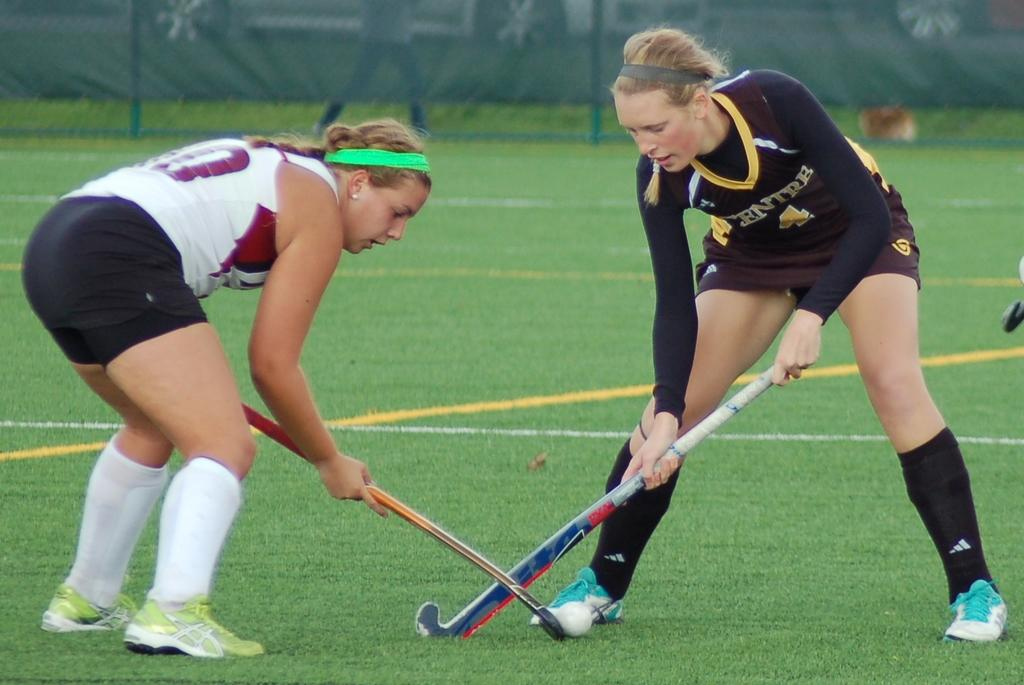How many people are in the image? There are two women in the image. What activity are the women engaged in? The women are playing hockey. What equipment are the women using to play hockey? The women are holding hockey sticks. What is on the grass in the image? There is a ball on the grass. What can be seen in the background of the image? There is a mesh visible in the background of the image. What type of pie is being served to the friend in the image? There is no friend or pie present in the image; it features two women playing hockey. 